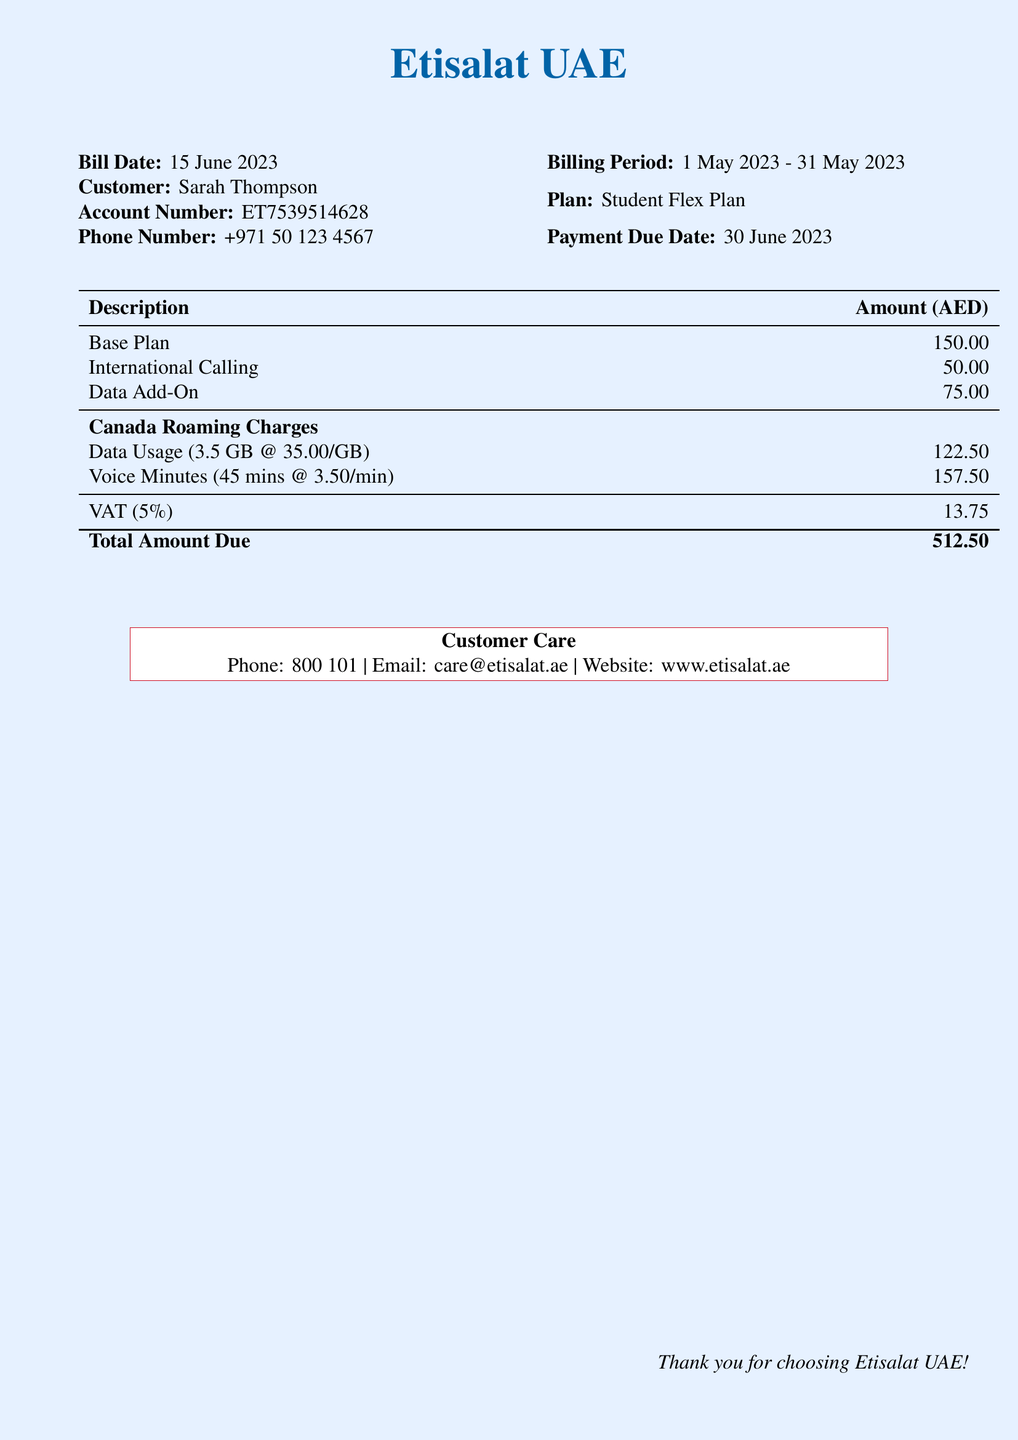what is the bill date? The bill date is specified under the billing details section of the document.
Answer: 15 June 2023 who is the customer? The customer's name is listed at the top of the document.
Answer: Sarah Thompson what is the account number? The account number is displayed next to the customer name.
Answer: ET7539514628 what is the total amount due? The total amount due is calculated at the bottom of the charges table in the document.
Answer: 512.50 how much was charged for data usage in Canada? The charge for data usage is listed under the Canada Roaming Charges section.
Answer: 122.50 how many voice minutes were used? The number of voice minutes used is stated in the breakdown of Canada Roaming Charges.
Answer: 45 mins what is the VAT amount? The VAT amount is detailed in the total calculation part of the bill.
Answer: 13.75 when is the payment due date? The payment due date is mentioned on the document along with the bill date.
Answer: 30 June 2023 what plan is the customer on? The plan information can be found in the customer details section of the bill.
Answer: Student Flex Plan 